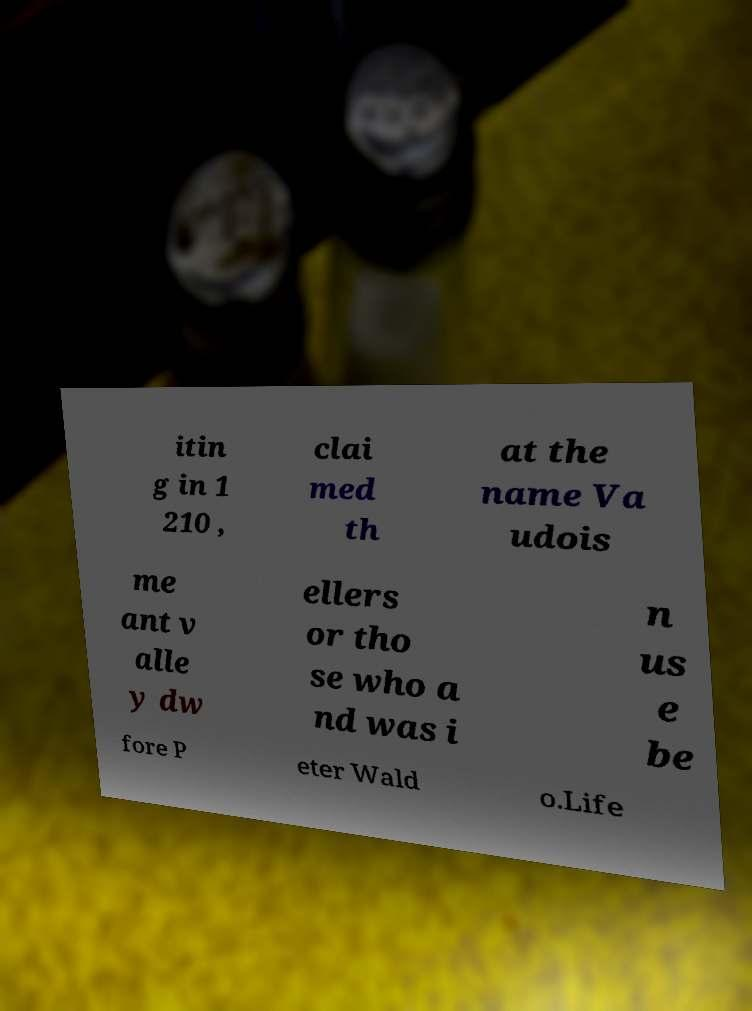Could you assist in decoding the text presented in this image and type it out clearly? itin g in 1 210 , clai med th at the name Va udois me ant v alle y dw ellers or tho se who a nd was i n us e be fore P eter Wald o.Life 